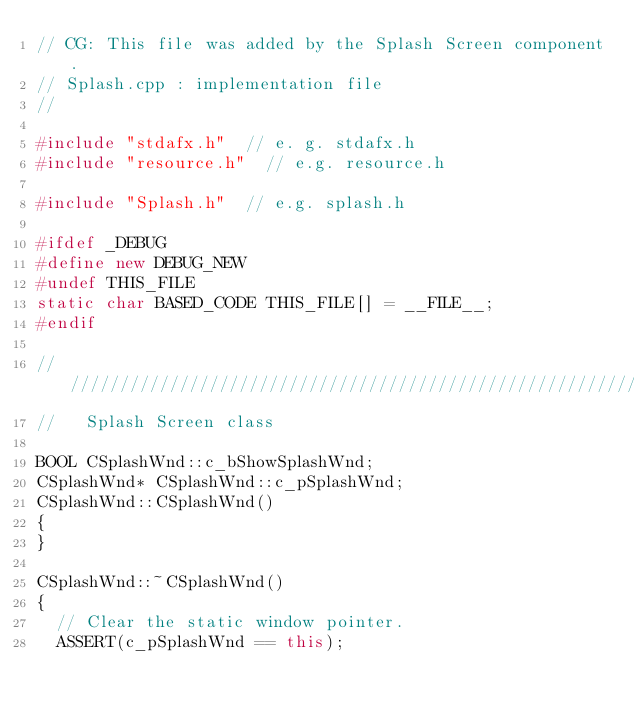<code> <loc_0><loc_0><loc_500><loc_500><_C++_>// CG: This file was added by the Splash Screen component.
// Splash.cpp : implementation file
//

#include "stdafx.h"  // e. g. stdafx.h
#include "resource.h"  // e.g. resource.h

#include "Splash.h"  // e.g. splash.h

#ifdef _DEBUG
#define new DEBUG_NEW
#undef THIS_FILE
static char BASED_CODE THIS_FILE[] = __FILE__;
#endif

/////////////////////////////////////////////////////////////////////////////
//   Splash Screen class

BOOL CSplashWnd::c_bShowSplashWnd;
CSplashWnd* CSplashWnd::c_pSplashWnd;
CSplashWnd::CSplashWnd()
{
}

CSplashWnd::~CSplashWnd()
{
	// Clear the static window pointer.
	ASSERT(c_pSplashWnd == this);</code> 